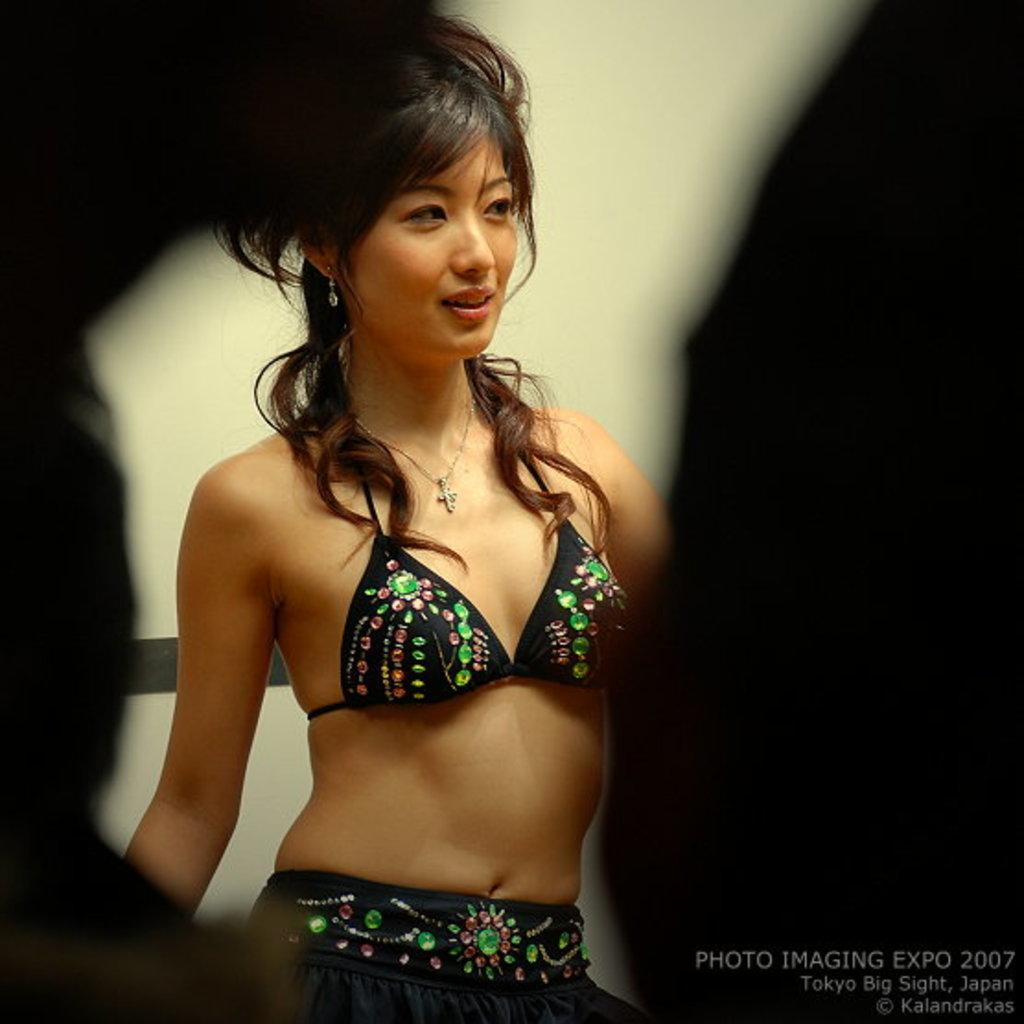Who is present in the image? There is a woman in the image. What is the woman's facial expression? The woman is smiling. How would you describe the lighting in the image? The sides of the image are a bit dark. What can be seen in the background of the image? There is a wall in the background of the image. What colors are used on the wall in the image? The wall is cream and black in color. What type of print is visible on the tray in the image? There is no tray present in the image, so it is not possible to determine if there is any print on it. 